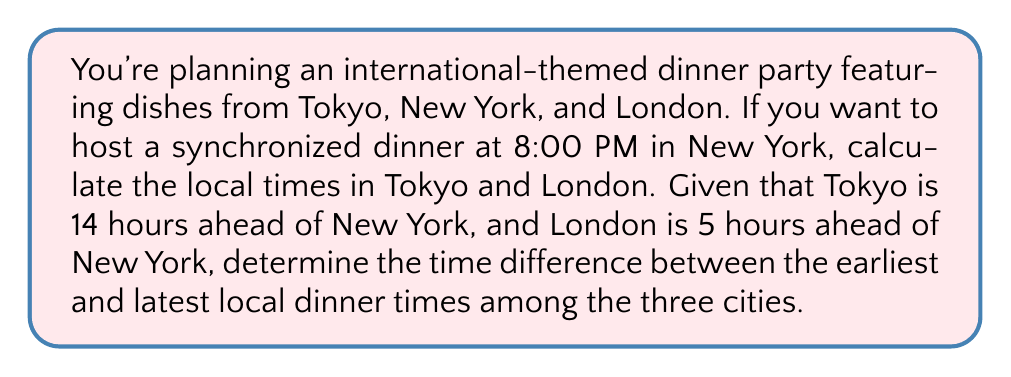Help me with this question. Let's approach this problem step-by-step:

1. Set up the reference time:
   New York time = 8:00 PM

2. Calculate Tokyo time:
   Tokyo is 14 hours ahead of New York
   Tokyo time = New York time + 14 hours
   $$ 8:00 \text{ PM} + 14 \text{ hours} = 10:00 \text{ AM} \text{ (next day)} $$

3. Calculate London time:
   London is 5 hours ahead of New York
   London time = New York time + 5 hours
   $$ 8:00 \text{ PM} + 5 \text{ hours} = 1:00 \text{ AM} \text{ (next day)} $$

4. Identify the earliest and latest dinner times:
   Earliest: Tokyo at 10:00 AM (next day)
   Latest: New York at 8:00 PM

5. Calculate the time difference:
   Time difference = Latest time - Earliest time
   $$ (8:00 \text{ PM} + 24 \text{ hours}) - 10:00 \text{ AM} = 22:00 \text{ hours} = 22 \text{ hours} $$

The addition of 24 hours to New York's time is necessary because it's on the previous day compared to Tokyo's time.
Answer: The time difference between the earliest and latest local dinner times is 22 hours. 